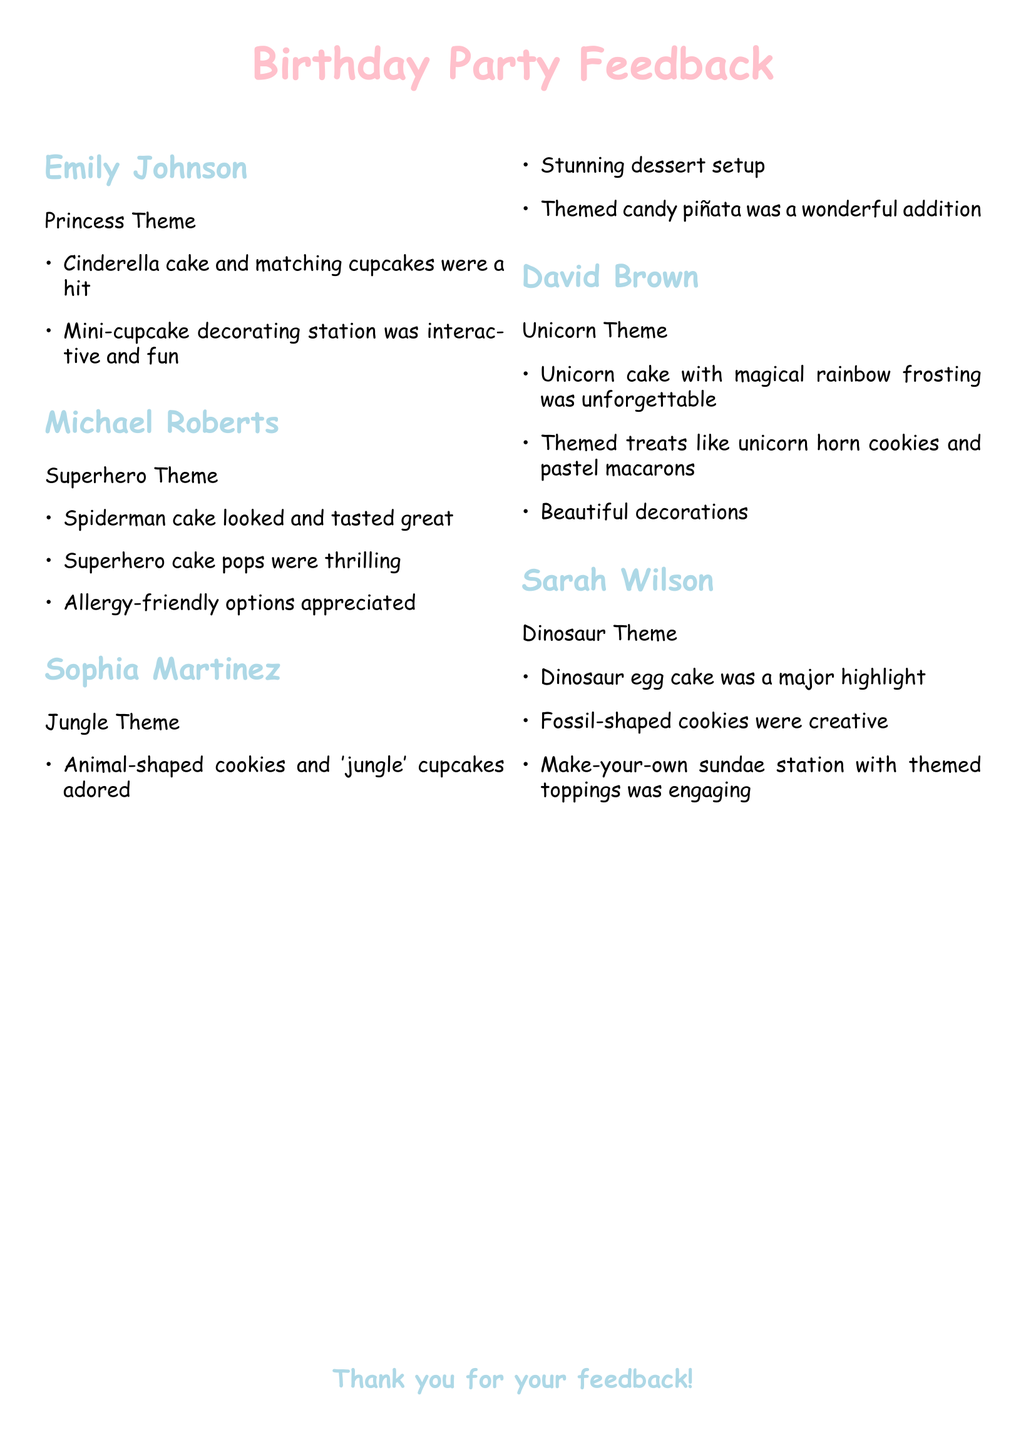What was the cake theme for Emily Johnson's party? Emily Johnson's party theme is Princess, which included a Cinderella cake.
Answer: Princess What type of dessert did Michael Roberts have that was allergy-friendly? Michael Roberts appreciated the allergy-friendly options provided at his Superhero themed party.
Answer: Options What unique dessert was part of Sophia Martinez's Jungle theme? Sophia Martinez's Jungle theme included animal-shaped cookies.
Answer: Animal-shaped cookies Which party had a make-your-own sundae station? The Dinosaur theme party, hosted by Sarah Wilson, featured a make-your-own sundae station.
Answer: Dinosaur Theme What was a major highlight of David Brown's Unicorn theme party? The major highlight of David Brown's Unicorn theme party was the unicorn cake with magical rainbow frosting.
Answer: Unicorn cake How many themes are mentioned in the document? The document lists five distinct themes based on the feedback provided by parents.
Answer: Five What color were David Brown's themed treats? David Brown's themed treats like the unicorn horn cookies were pastel in color.
Answer: Pastel What type of dessert was featured in Sophia Martinez's party? Themed candy piñata was featured as part of Sophia Martinez's dessert setup for her Jungle theme party.
Answer: Candy piñata 